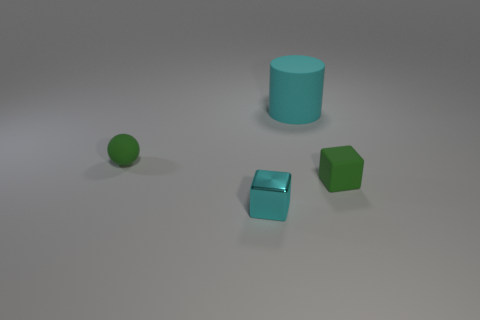Are there any balls of the same size as the cyan block?
Offer a very short reply. Yes. The metallic thing has what color?
Provide a short and direct response. Cyan. Is the size of the ball the same as the cylinder?
Offer a terse response. No. What number of things are either tiny green matte balls or tiny metal blocks?
Ensure brevity in your answer.  2. Are there the same number of tiny green things that are in front of the tiny green cube and small red cylinders?
Offer a very short reply. Yes. There is a small rubber thing in front of the green matte object to the left of the tiny metallic object; is there a green matte object behind it?
Make the answer very short. Yes. What color is the sphere that is the same material as the big cylinder?
Your response must be concise. Green. There is a matte thing left of the cylinder; is it the same color as the small rubber cube?
Ensure brevity in your answer.  Yes. How many balls are either small blue things or large matte objects?
Give a very brief answer. 0. There is a matte object that is in front of the tiny green thing behind the green cube that is to the right of the tiny green rubber ball; what is its size?
Your answer should be very brief. Small. 